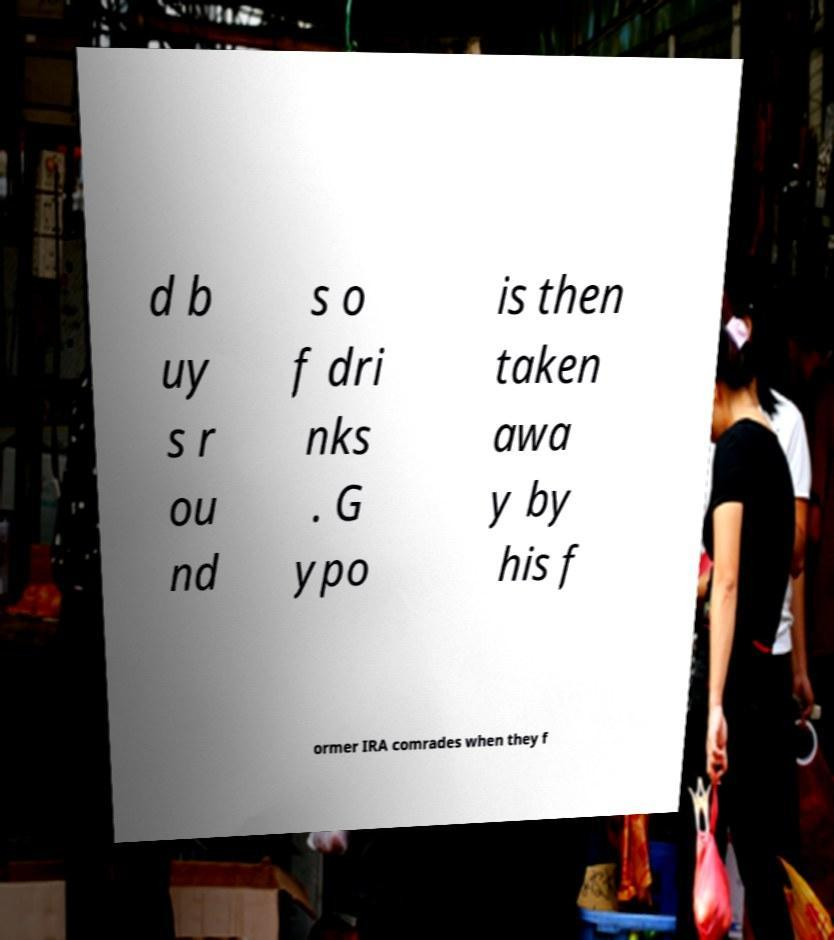For documentation purposes, I need the text within this image transcribed. Could you provide that? d b uy s r ou nd s o f dri nks . G ypo is then taken awa y by his f ormer IRA comrades when they f 